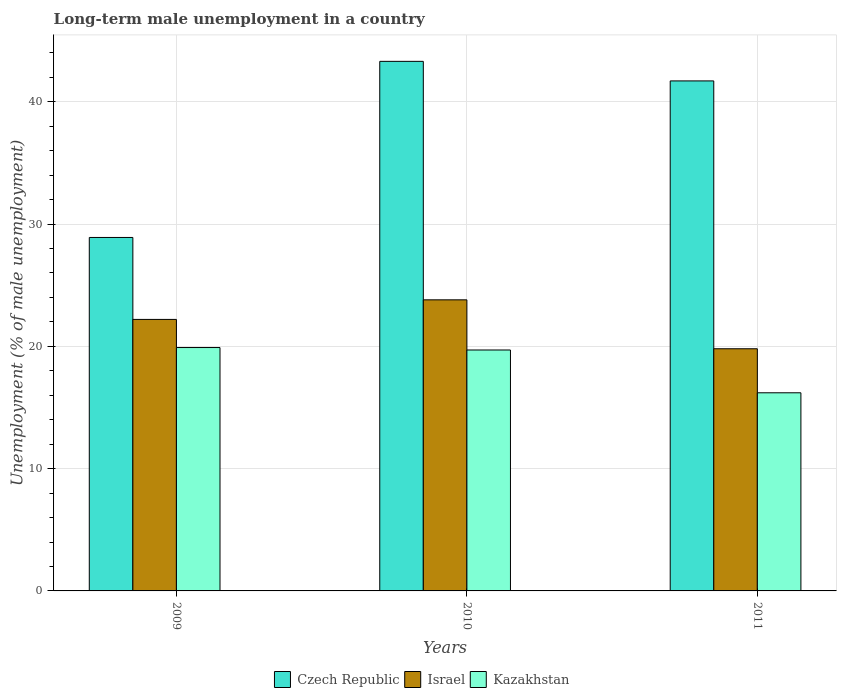How many bars are there on the 1st tick from the left?
Offer a very short reply. 3. How many bars are there on the 2nd tick from the right?
Offer a very short reply. 3. What is the label of the 1st group of bars from the left?
Make the answer very short. 2009. In how many cases, is the number of bars for a given year not equal to the number of legend labels?
Offer a terse response. 0. What is the percentage of long-term unemployed male population in Kazakhstan in 2010?
Provide a succinct answer. 19.7. Across all years, what is the maximum percentage of long-term unemployed male population in Czech Republic?
Your response must be concise. 43.3. Across all years, what is the minimum percentage of long-term unemployed male population in Israel?
Make the answer very short. 19.8. What is the total percentage of long-term unemployed male population in Czech Republic in the graph?
Offer a terse response. 113.9. What is the difference between the percentage of long-term unemployed male population in Kazakhstan in 2009 and that in 2011?
Give a very brief answer. 3.7. What is the difference between the percentage of long-term unemployed male population in Kazakhstan in 2010 and the percentage of long-term unemployed male population in Czech Republic in 2009?
Offer a very short reply. -9.2. What is the average percentage of long-term unemployed male population in Kazakhstan per year?
Your answer should be very brief. 18.6. In the year 2011, what is the difference between the percentage of long-term unemployed male population in Kazakhstan and percentage of long-term unemployed male population in Israel?
Keep it short and to the point. -3.6. In how many years, is the percentage of long-term unemployed male population in Kazakhstan greater than 28 %?
Your answer should be very brief. 0. What is the ratio of the percentage of long-term unemployed male population in Czech Republic in 2010 to that in 2011?
Your answer should be very brief. 1.04. Is the difference between the percentage of long-term unemployed male population in Kazakhstan in 2010 and 2011 greater than the difference between the percentage of long-term unemployed male population in Israel in 2010 and 2011?
Make the answer very short. No. What is the difference between the highest and the second highest percentage of long-term unemployed male population in Kazakhstan?
Make the answer very short. 0.2. What is the difference between the highest and the lowest percentage of long-term unemployed male population in Kazakhstan?
Your response must be concise. 3.7. In how many years, is the percentage of long-term unemployed male population in Czech Republic greater than the average percentage of long-term unemployed male population in Czech Republic taken over all years?
Your response must be concise. 2. Is the sum of the percentage of long-term unemployed male population in Czech Republic in 2010 and 2011 greater than the maximum percentage of long-term unemployed male population in Israel across all years?
Your response must be concise. Yes. What does the 3rd bar from the left in 2011 represents?
Give a very brief answer. Kazakhstan. What does the 3rd bar from the right in 2011 represents?
Offer a terse response. Czech Republic. Are all the bars in the graph horizontal?
Your answer should be compact. No. What is the difference between two consecutive major ticks on the Y-axis?
Offer a terse response. 10. Are the values on the major ticks of Y-axis written in scientific E-notation?
Offer a very short reply. No. How many legend labels are there?
Your answer should be compact. 3. How are the legend labels stacked?
Your answer should be compact. Horizontal. What is the title of the graph?
Provide a short and direct response. Long-term male unemployment in a country. What is the label or title of the X-axis?
Offer a very short reply. Years. What is the label or title of the Y-axis?
Provide a succinct answer. Unemployment (% of male unemployment). What is the Unemployment (% of male unemployment) of Czech Republic in 2009?
Provide a short and direct response. 28.9. What is the Unemployment (% of male unemployment) of Israel in 2009?
Ensure brevity in your answer.  22.2. What is the Unemployment (% of male unemployment) in Kazakhstan in 2009?
Make the answer very short. 19.9. What is the Unemployment (% of male unemployment) of Czech Republic in 2010?
Make the answer very short. 43.3. What is the Unemployment (% of male unemployment) of Israel in 2010?
Offer a terse response. 23.8. What is the Unemployment (% of male unemployment) of Kazakhstan in 2010?
Make the answer very short. 19.7. What is the Unemployment (% of male unemployment) of Czech Republic in 2011?
Offer a terse response. 41.7. What is the Unemployment (% of male unemployment) in Israel in 2011?
Make the answer very short. 19.8. What is the Unemployment (% of male unemployment) of Kazakhstan in 2011?
Offer a very short reply. 16.2. Across all years, what is the maximum Unemployment (% of male unemployment) in Czech Republic?
Your answer should be very brief. 43.3. Across all years, what is the maximum Unemployment (% of male unemployment) of Israel?
Your answer should be compact. 23.8. Across all years, what is the maximum Unemployment (% of male unemployment) in Kazakhstan?
Make the answer very short. 19.9. Across all years, what is the minimum Unemployment (% of male unemployment) of Czech Republic?
Provide a short and direct response. 28.9. Across all years, what is the minimum Unemployment (% of male unemployment) in Israel?
Your answer should be compact. 19.8. Across all years, what is the minimum Unemployment (% of male unemployment) of Kazakhstan?
Your answer should be compact. 16.2. What is the total Unemployment (% of male unemployment) of Czech Republic in the graph?
Give a very brief answer. 113.9. What is the total Unemployment (% of male unemployment) in Israel in the graph?
Make the answer very short. 65.8. What is the total Unemployment (% of male unemployment) in Kazakhstan in the graph?
Give a very brief answer. 55.8. What is the difference between the Unemployment (% of male unemployment) of Czech Republic in 2009 and that in 2010?
Offer a very short reply. -14.4. What is the difference between the Unemployment (% of male unemployment) in Kazakhstan in 2009 and that in 2010?
Keep it short and to the point. 0.2. What is the difference between the Unemployment (% of male unemployment) in Czech Republic in 2009 and that in 2011?
Keep it short and to the point. -12.8. What is the difference between the Unemployment (% of male unemployment) in Israel in 2010 and that in 2011?
Your answer should be compact. 4. What is the difference between the Unemployment (% of male unemployment) in Israel in 2009 and the Unemployment (% of male unemployment) in Kazakhstan in 2010?
Provide a short and direct response. 2.5. What is the difference between the Unemployment (% of male unemployment) of Czech Republic in 2009 and the Unemployment (% of male unemployment) of Israel in 2011?
Provide a succinct answer. 9.1. What is the difference between the Unemployment (% of male unemployment) of Israel in 2009 and the Unemployment (% of male unemployment) of Kazakhstan in 2011?
Your answer should be compact. 6. What is the difference between the Unemployment (% of male unemployment) of Czech Republic in 2010 and the Unemployment (% of male unemployment) of Kazakhstan in 2011?
Ensure brevity in your answer.  27.1. What is the difference between the Unemployment (% of male unemployment) of Israel in 2010 and the Unemployment (% of male unemployment) of Kazakhstan in 2011?
Offer a terse response. 7.6. What is the average Unemployment (% of male unemployment) in Czech Republic per year?
Keep it short and to the point. 37.97. What is the average Unemployment (% of male unemployment) of Israel per year?
Ensure brevity in your answer.  21.93. What is the average Unemployment (% of male unemployment) in Kazakhstan per year?
Your response must be concise. 18.6. In the year 2009, what is the difference between the Unemployment (% of male unemployment) in Czech Republic and Unemployment (% of male unemployment) in Kazakhstan?
Make the answer very short. 9. In the year 2009, what is the difference between the Unemployment (% of male unemployment) in Israel and Unemployment (% of male unemployment) in Kazakhstan?
Keep it short and to the point. 2.3. In the year 2010, what is the difference between the Unemployment (% of male unemployment) of Czech Republic and Unemployment (% of male unemployment) of Israel?
Ensure brevity in your answer.  19.5. In the year 2010, what is the difference between the Unemployment (% of male unemployment) of Czech Republic and Unemployment (% of male unemployment) of Kazakhstan?
Your answer should be very brief. 23.6. In the year 2011, what is the difference between the Unemployment (% of male unemployment) of Czech Republic and Unemployment (% of male unemployment) of Israel?
Offer a very short reply. 21.9. In the year 2011, what is the difference between the Unemployment (% of male unemployment) of Israel and Unemployment (% of male unemployment) of Kazakhstan?
Offer a terse response. 3.6. What is the ratio of the Unemployment (% of male unemployment) of Czech Republic in 2009 to that in 2010?
Provide a succinct answer. 0.67. What is the ratio of the Unemployment (% of male unemployment) of Israel in 2009 to that in 2010?
Offer a very short reply. 0.93. What is the ratio of the Unemployment (% of male unemployment) of Kazakhstan in 2009 to that in 2010?
Make the answer very short. 1.01. What is the ratio of the Unemployment (% of male unemployment) in Czech Republic in 2009 to that in 2011?
Offer a very short reply. 0.69. What is the ratio of the Unemployment (% of male unemployment) of Israel in 2009 to that in 2011?
Your answer should be very brief. 1.12. What is the ratio of the Unemployment (% of male unemployment) in Kazakhstan in 2009 to that in 2011?
Provide a short and direct response. 1.23. What is the ratio of the Unemployment (% of male unemployment) of Czech Republic in 2010 to that in 2011?
Offer a very short reply. 1.04. What is the ratio of the Unemployment (% of male unemployment) of Israel in 2010 to that in 2011?
Provide a succinct answer. 1.2. What is the ratio of the Unemployment (% of male unemployment) of Kazakhstan in 2010 to that in 2011?
Offer a terse response. 1.22. 